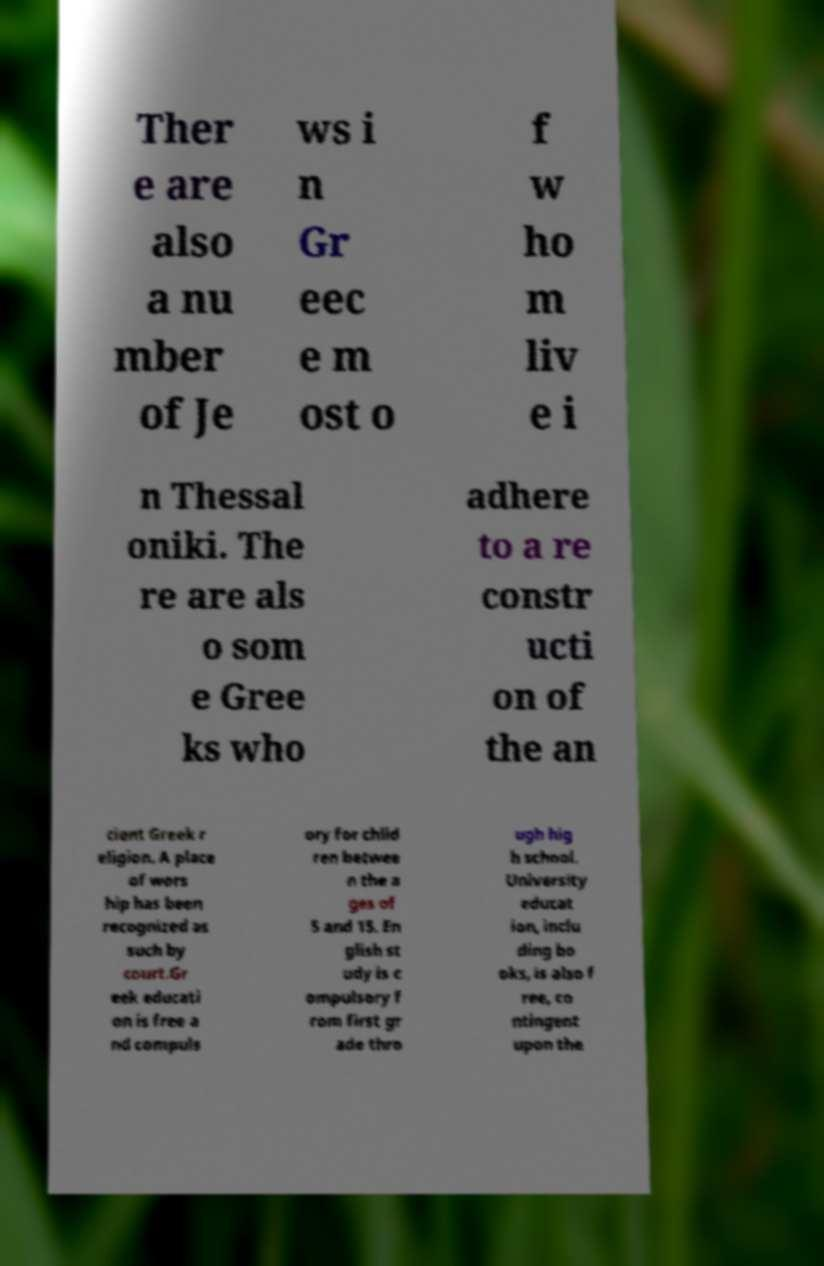Please read and relay the text visible in this image. What does it say? Ther e are also a nu mber of Je ws i n Gr eec e m ost o f w ho m liv e i n Thessal oniki. The re are als o som e Gree ks who adhere to a re constr ucti on of the an cient Greek r eligion. A place of wors hip has been recognized as such by court.Gr eek educati on is free a nd compuls ory for child ren betwee n the a ges of 5 and 15. En glish st udy is c ompulsory f rom first gr ade thro ugh hig h school. University educat ion, inclu ding bo oks, is also f ree, co ntingent upon the 